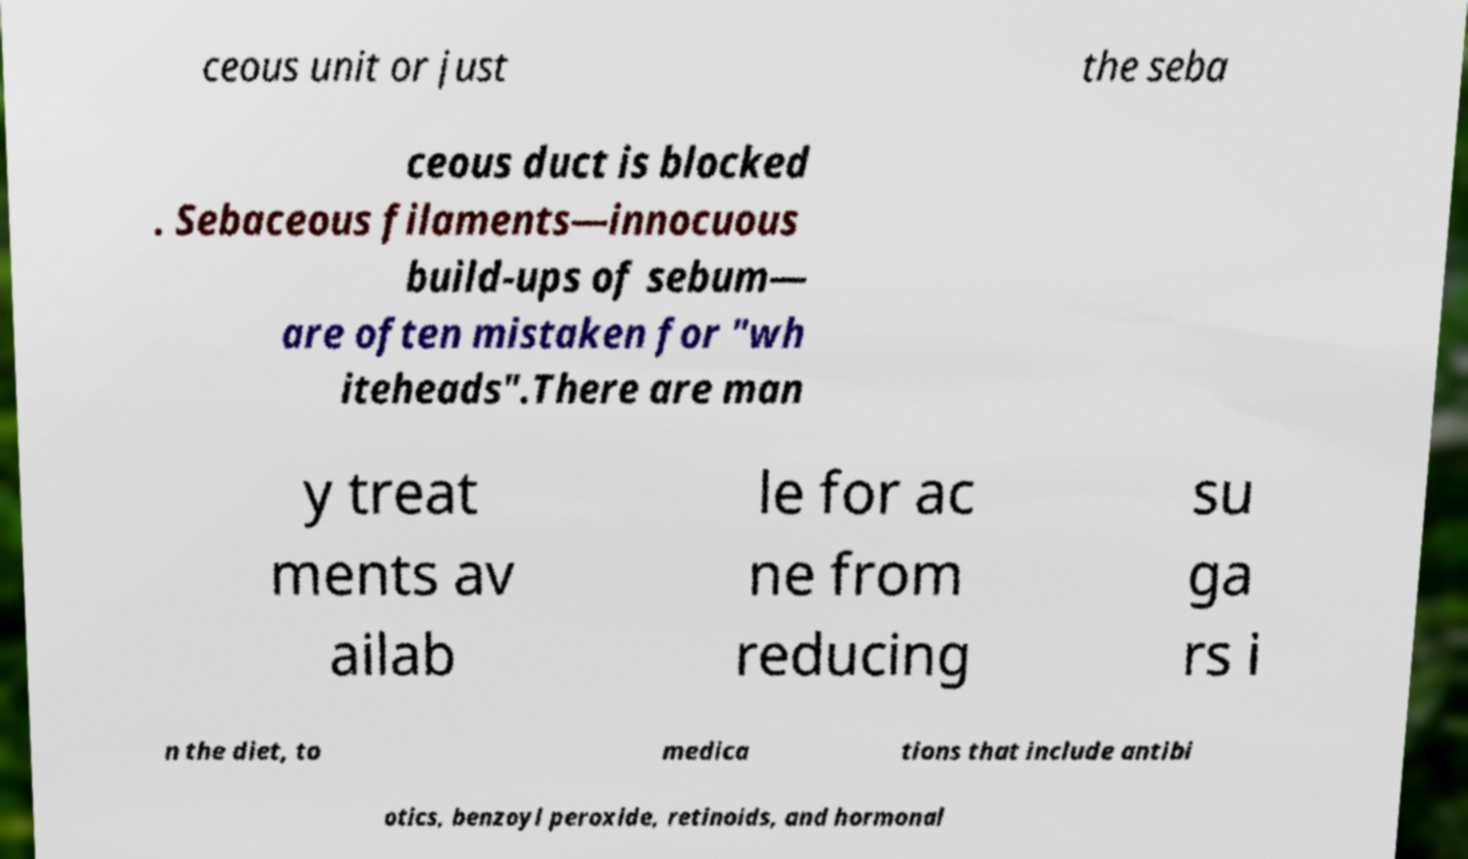For documentation purposes, I need the text within this image transcribed. Could you provide that? ceous unit or just the seba ceous duct is blocked . Sebaceous filaments—innocuous build-ups of sebum— are often mistaken for "wh iteheads".There are man y treat ments av ailab le for ac ne from reducing su ga rs i n the diet, to medica tions that include antibi otics, benzoyl peroxide, retinoids, and hormonal 